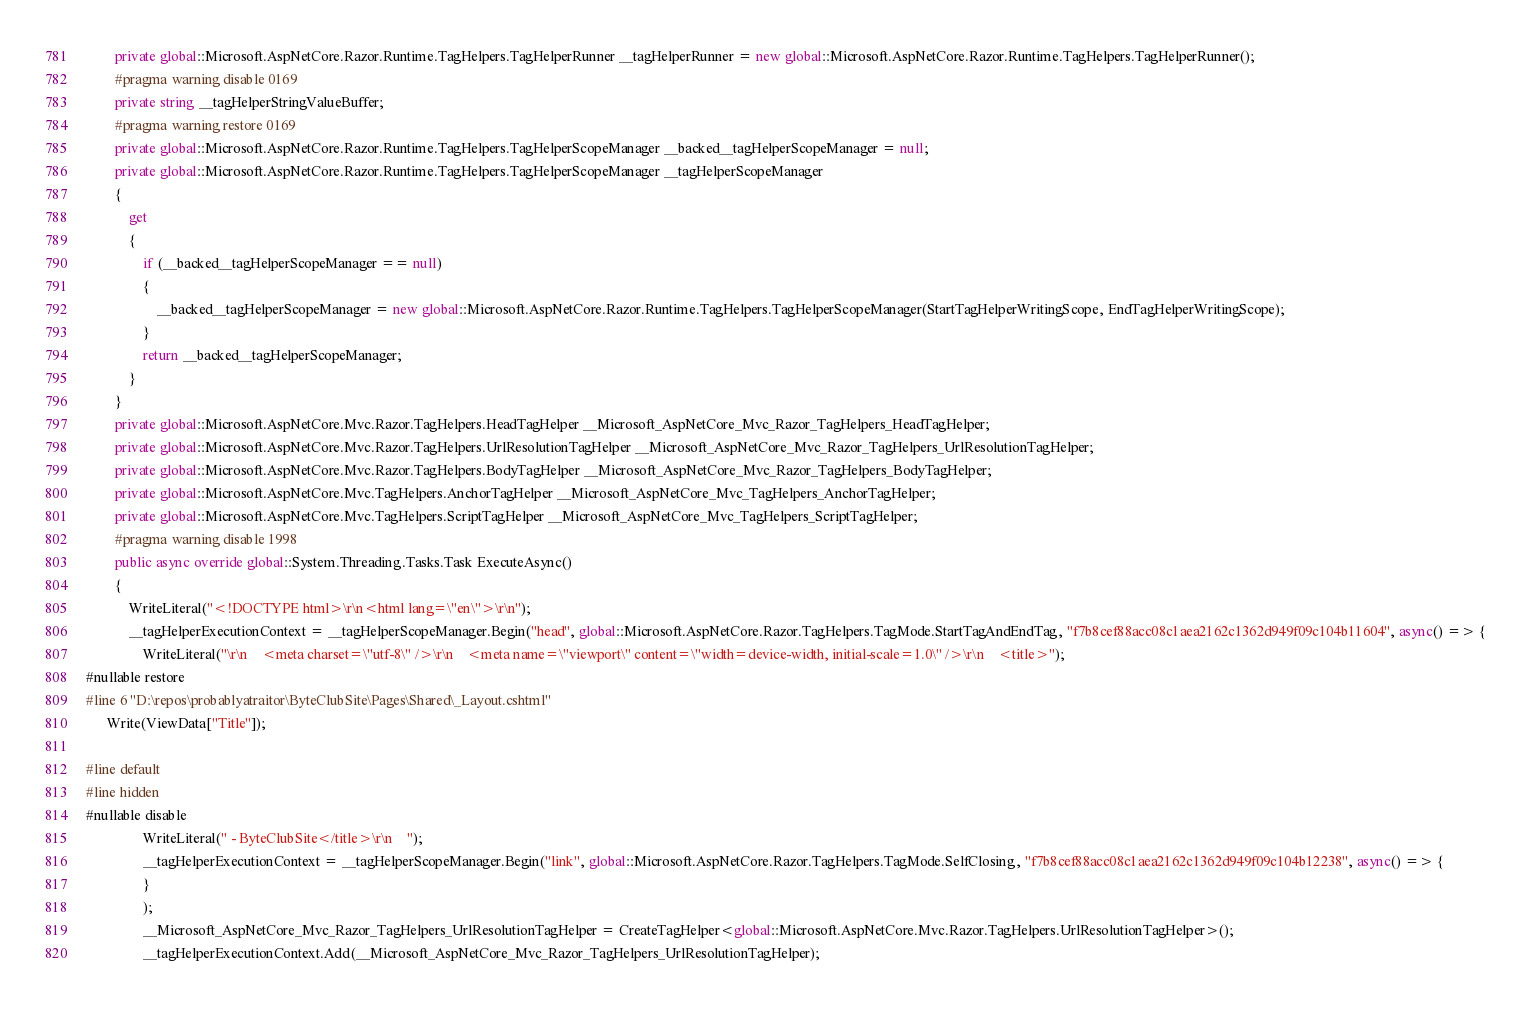Convert code to text. <code><loc_0><loc_0><loc_500><loc_500><_C#_>        private global::Microsoft.AspNetCore.Razor.Runtime.TagHelpers.TagHelperRunner __tagHelperRunner = new global::Microsoft.AspNetCore.Razor.Runtime.TagHelpers.TagHelperRunner();
        #pragma warning disable 0169
        private string __tagHelperStringValueBuffer;
        #pragma warning restore 0169
        private global::Microsoft.AspNetCore.Razor.Runtime.TagHelpers.TagHelperScopeManager __backed__tagHelperScopeManager = null;
        private global::Microsoft.AspNetCore.Razor.Runtime.TagHelpers.TagHelperScopeManager __tagHelperScopeManager
        {
            get
            {
                if (__backed__tagHelperScopeManager == null)
                {
                    __backed__tagHelperScopeManager = new global::Microsoft.AspNetCore.Razor.Runtime.TagHelpers.TagHelperScopeManager(StartTagHelperWritingScope, EndTagHelperWritingScope);
                }
                return __backed__tagHelperScopeManager;
            }
        }
        private global::Microsoft.AspNetCore.Mvc.Razor.TagHelpers.HeadTagHelper __Microsoft_AspNetCore_Mvc_Razor_TagHelpers_HeadTagHelper;
        private global::Microsoft.AspNetCore.Mvc.Razor.TagHelpers.UrlResolutionTagHelper __Microsoft_AspNetCore_Mvc_Razor_TagHelpers_UrlResolutionTagHelper;
        private global::Microsoft.AspNetCore.Mvc.Razor.TagHelpers.BodyTagHelper __Microsoft_AspNetCore_Mvc_Razor_TagHelpers_BodyTagHelper;
        private global::Microsoft.AspNetCore.Mvc.TagHelpers.AnchorTagHelper __Microsoft_AspNetCore_Mvc_TagHelpers_AnchorTagHelper;
        private global::Microsoft.AspNetCore.Mvc.TagHelpers.ScriptTagHelper __Microsoft_AspNetCore_Mvc_TagHelpers_ScriptTagHelper;
        #pragma warning disable 1998
        public async override global::System.Threading.Tasks.Task ExecuteAsync()
        {
            WriteLiteral("<!DOCTYPE html>\r\n<html lang=\"en\">\r\n");
            __tagHelperExecutionContext = __tagHelperScopeManager.Begin("head", global::Microsoft.AspNetCore.Razor.TagHelpers.TagMode.StartTagAndEndTag, "f7b8cef88acc08c1aea2162c1362d949f09c104b11604", async() => {
                WriteLiteral("\r\n    <meta charset=\"utf-8\" />\r\n    <meta name=\"viewport\" content=\"width=device-width, initial-scale=1.0\" />\r\n    <title>");
#nullable restore
#line 6 "D:\repos\probablyatraitor\ByteClubSite\Pages\Shared\_Layout.cshtml"
      Write(ViewData["Title"]);

#line default
#line hidden
#nullable disable
                WriteLiteral(" - ByteClubSite</title>\r\n    ");
                __tagHelperExecutionContext = __tagHelperScopeManager.Begin("link", global::Microsoft.AspNetCore.Razor.TagHelpers.TagMode.SelfClosing, "f7b8cef88acc08c1aea2162c1362d949f09c104b12238", async() => {
                }
                );
                __Microsoft_AspNetCore_Mvc_Razor_TagHelpers_UrlResolutionTagHelper = CreateTagHelper<global::Microsoft.AspNetCore.Mvc.Razor.TagHelpers.UrlResolutionTagHelper>();
                __tagHelperExecutionContext.Add(__Microsoft_AspNetCore_Mvc_Razor_TagHelpers_UrlResolutionTagHelper);</code> 